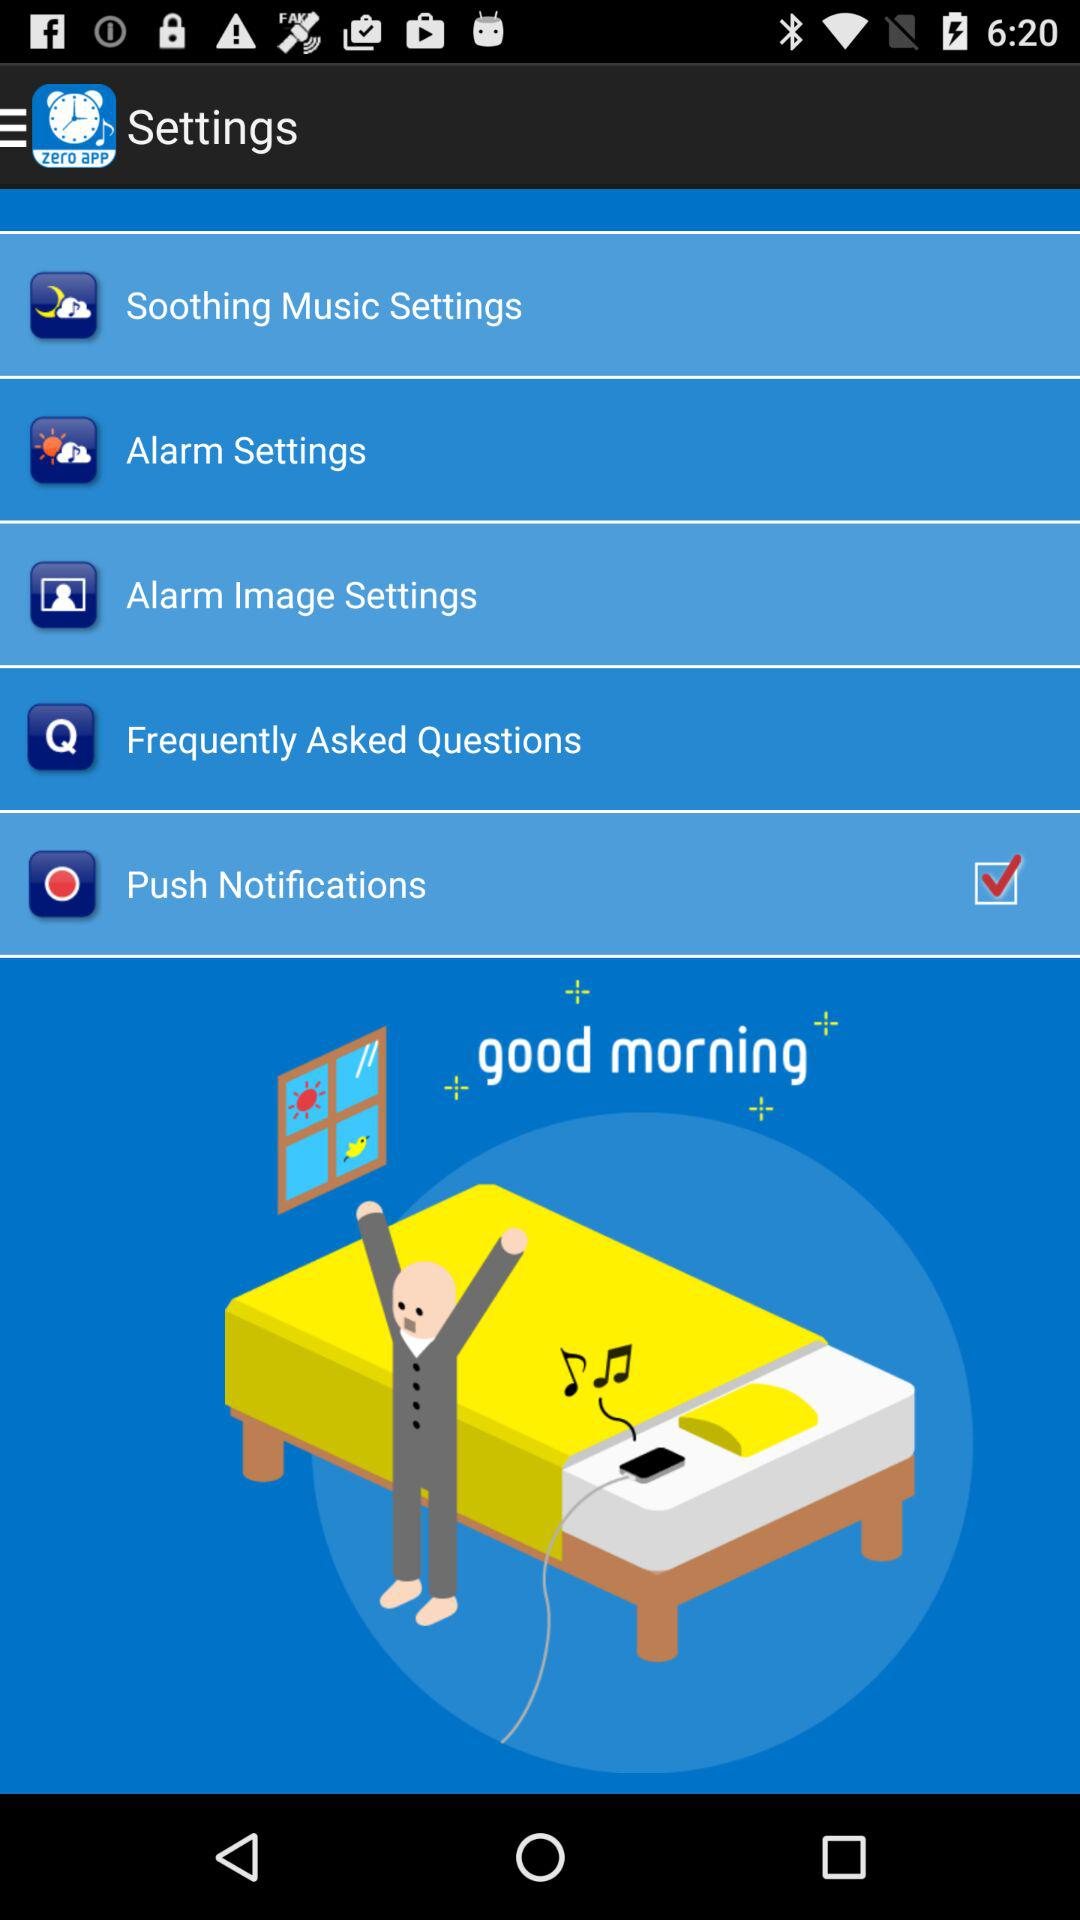What is the status of the "Push Notifications"? The status is "on". 